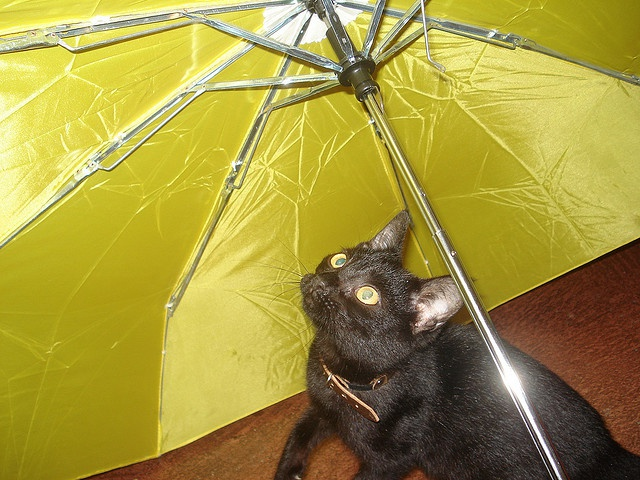Describe the objects in this image and their specific colors. I can see umbrella in yellow, olive, khaki, and gold tones and cat in yellow, black, and gray tones in this image. 